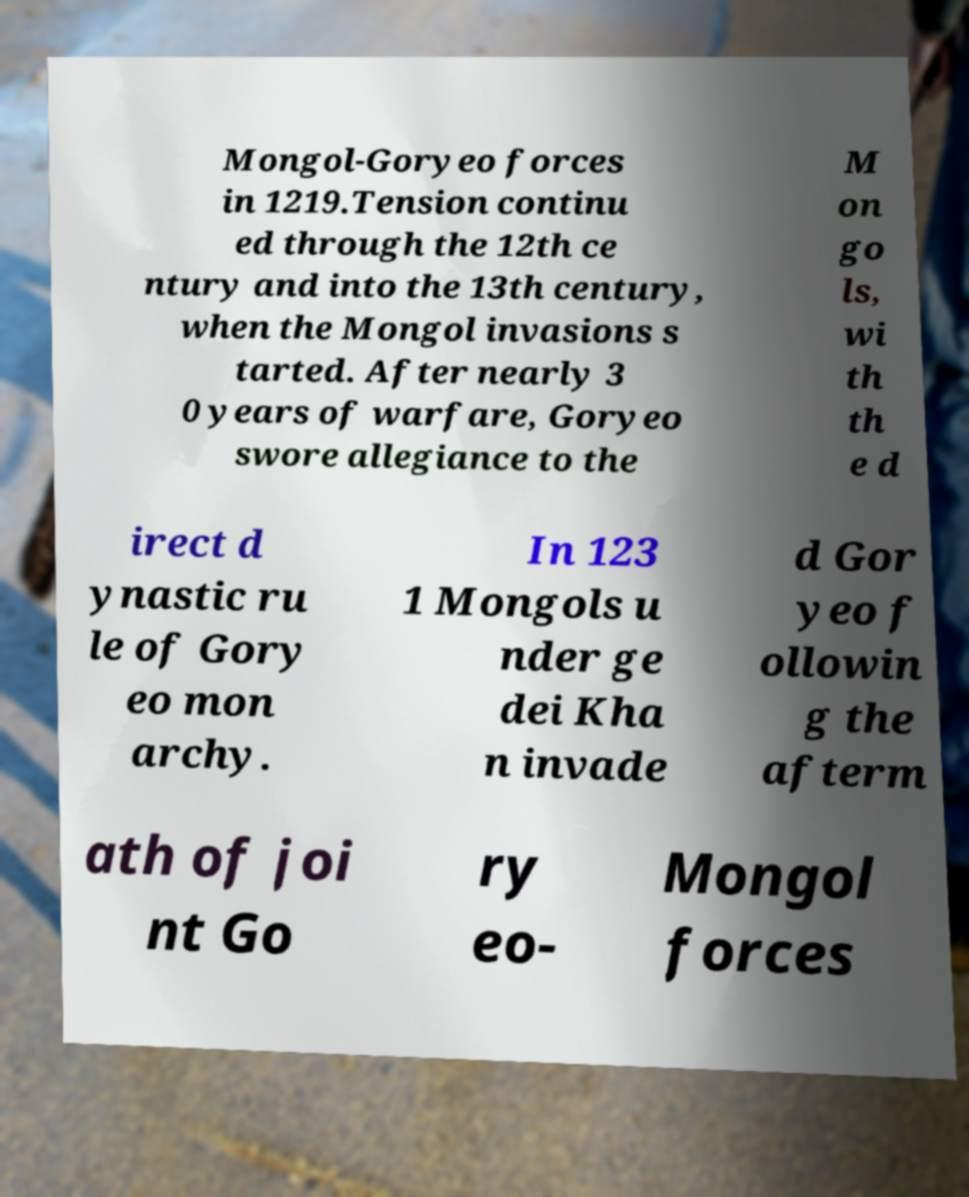Please identify and transcribe the text found in this image. Mongol-Goryeo forces in 1219.Tension continu ed through the 12th ce ntury and into the 13th century, when the Mongol invasions s tarted. After nearly 3 0 years of warfare, Goryeo swore allegiance to the M on go ls, wi th th e d irect d ynastic ru le of Gory eo mon archy. In 123 1 Mongols u nder ge dei Kha n invade d Gor yeo f ollowin g the afterm ath of joi nt Go ry eo- Mongol forces 